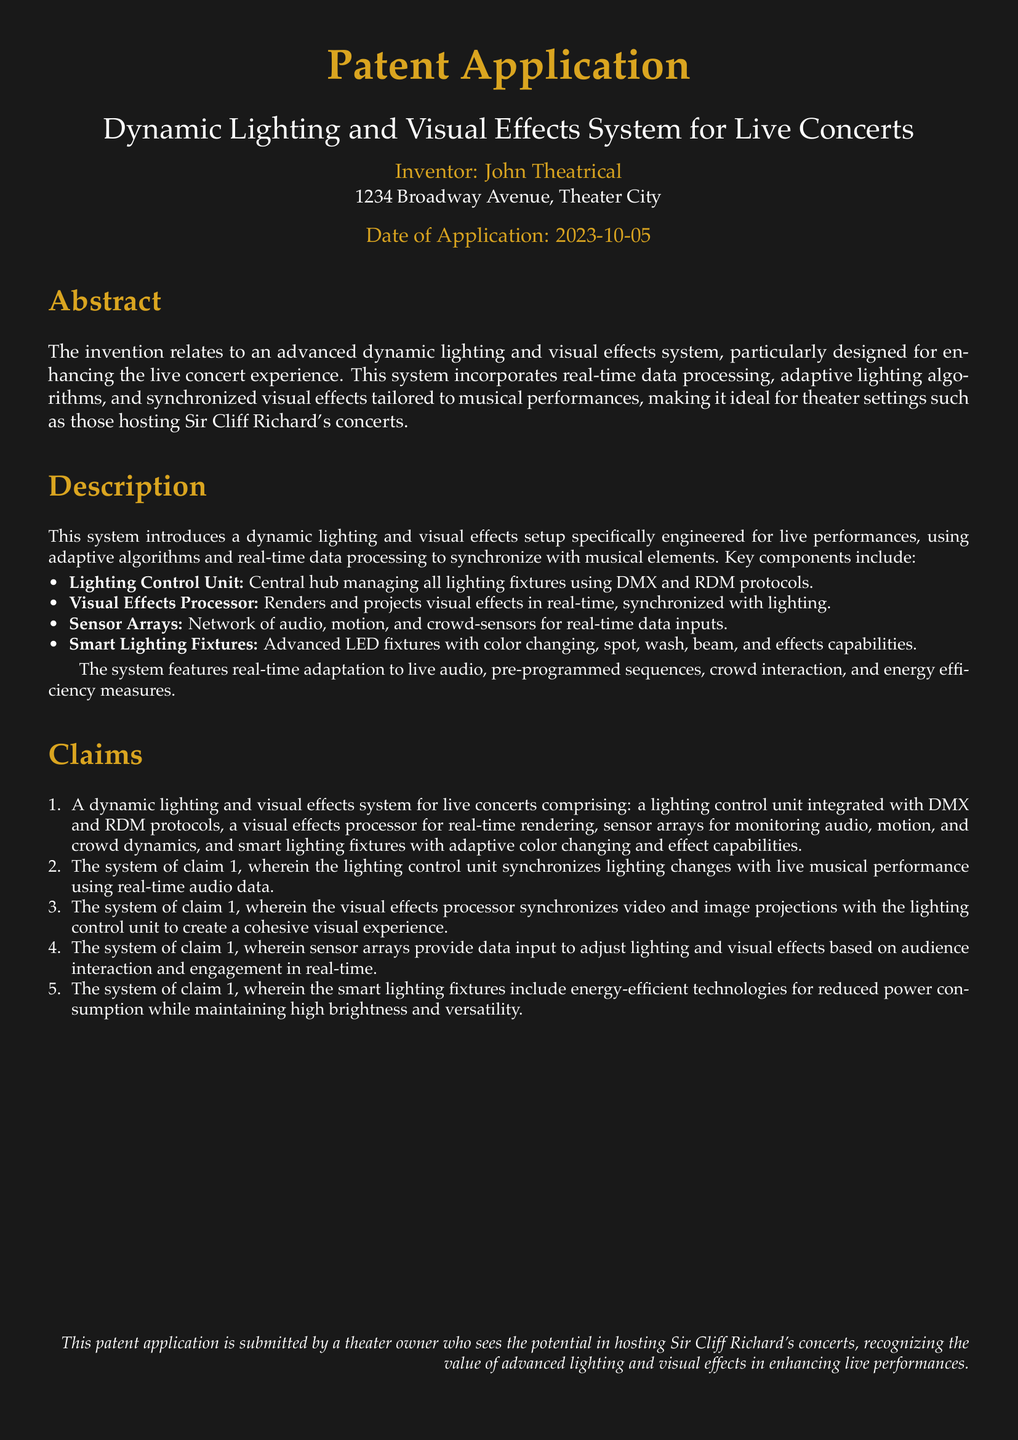What is the title of the patent application? The title is an essential part of the document that identifies the invention and its purpose.
Answer: Dynamic Lighting and Visual Effects System for Live Concerts Who is the inventor of the patent? The inventor's name is listed clearly in the document which shows the person responsible for the invention.
Answer: John Theatrical What date was the patent application submitted? The date helps to track the application and its timeline which is significant in patent processes.
Answer: 2023-10-05 What is the main purpose of the dynamic lighting and visual effects system? This section describes the overarching goal of the invention and why it exists, making it clear for potential users or reviewers.
Answer: Enhancing the live concert experience How does the lighting control unit synchronize changes? This question requires correlating various functions of the system as described in the claims section.
Answer: With real-time audio data What are the key components of the system? This question focuses on the main elements that comprise the invention which are crucial for understanding its functionality.
Answer: Lighting Control Unit, Visual Effects Processor, Sensor Arrays, Smart Lighting Fixtures What does the visual effects processor do? This question is about the specific function of a key component in the system and is related to the description of the invention.
Answer: Renders and projects visual effects in real-time How do sensor arrays contribute to the system? This question examines the role of a component within the overall system functionality and its importance in live performances.
Answer: Provide data input to adjust lighting and visual effects What advantage do smart lighting fixtures provide? This question focuses on the energy aspect of the components and highlights technological advancements described in the claims.
Answer: Energy-efficient technologies What is a key feature of the smart lighting fixtures? This question addresses a specific characteristic that enhances the usage of the fixtures in the system.
Answer: Adaptive color changing and effect capabilities 